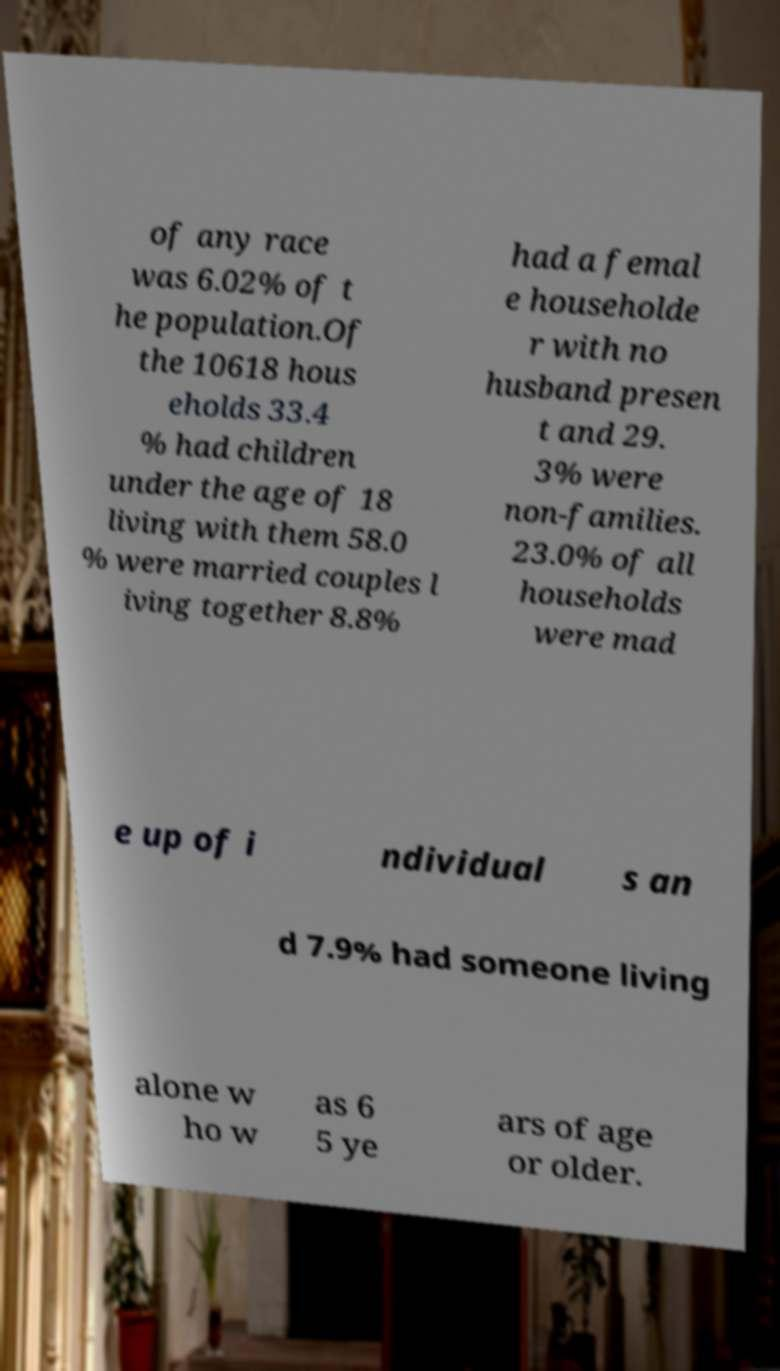Please read and relay the text visible in this image. What does it say? of any race was 6.02% of t he population.Of the 10618 hous eholds 33.4 % had children under the age of 18 living with them 58.0 % were married couples l iving together 8.8% had a femal e householde r with no husband presen t and 29. 3% were non-families. 23.0% of all households were mad e up of i ndividual s an d 7.9% had someone living alone w ho w as 6 5 ye ars of age or older. 